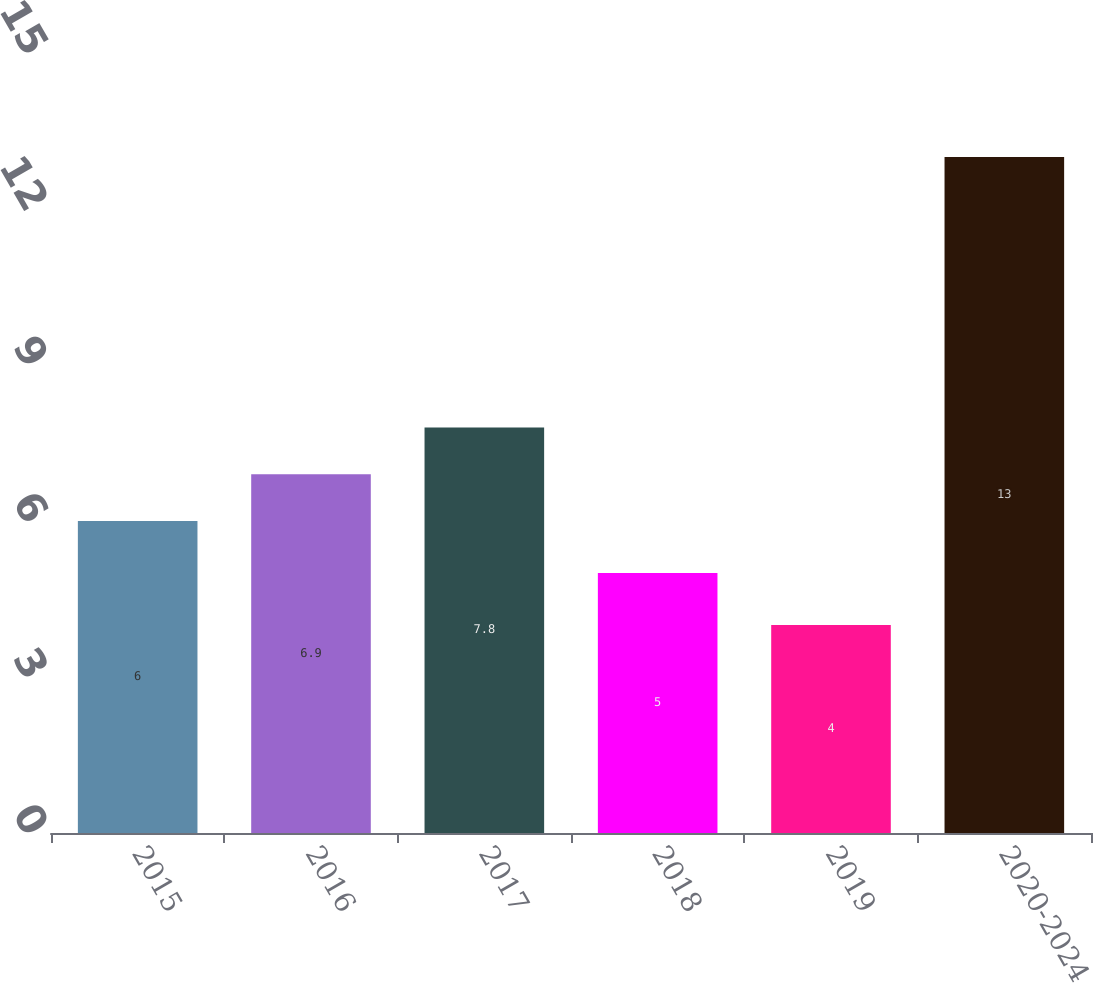Convert chart to OTSL. <chart><loc_0><loc_0><loc_500><loc_500><bar_chart><fcel>2015<fcel>2016<fcel>2017<fcel>2018<fcel>2019<fcel>2020-2024<nl><fcel>6<fcel>6.9<fcel>7.8<fcel>5<fcel>4<fcel>13<nl></chart> 